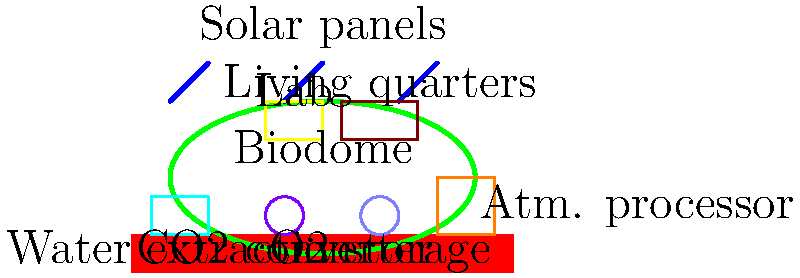In the schematic of a Martian terraforming facility, which component is most likely responsible for the initial production of breathable air, a crucial element in Ben Bova's Mars terraforming scenarios? To answer this question, let's analyze the components of the terraforming facility shown in the schematic:

1. Biodome: This is likely for growing plants and creating a controlled environment, but not the initial source of breathable air.

2. Solar panels: These provide power to the facility but don't directly produce air.

3. Water extraction facility: This extracts water from the Martian soil or ice, which is essential but not directly related to air production.

4. Atmospheric processor: This large structure is designed to process the Martian atmosphere, which is a crucial step in terraforming.

5. CO2 converter: This small unit is likely designed to convert CO2 into other substances, possibly oxygen.

6. O2 storage: This stores oxygen but doesn't produce it.

7. Lab and Living quarters: These are for research and habitation, not air production.

The atmospheric processor is the largest structure dedicated to manipulating the Martian atmosphere. In Ben Bova's Mars novels, the initial stages of terraforming often involve processing the existing CO2-rich Martian atmosphere to create breathable air.

The atmospheric processor would likely perform the following functions:
1. Extract and concentrate gases from the thin Martian atmosphere
2. Break down CO2 into oxygen and carbon monoxide
3. Filter out harmful particles and gases

While the CO2 converter might play a role, its small size suggests it's more for fine-tuning or specific experiments rather than large-scale air production.

Therefore, the atmospheric processor is most likely responsible for the initial production of breathable air in this terraforming scenario.
Answer: Atmospheric processor 